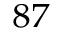Convert formula to latex. <formula><loc_0><loc_0><loc_500><loc_500>^ { 8 7 }</formula> 